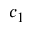<formula> <loc_0><loc_0><loc_500><loc_500>c _ { 1 }</formula> 